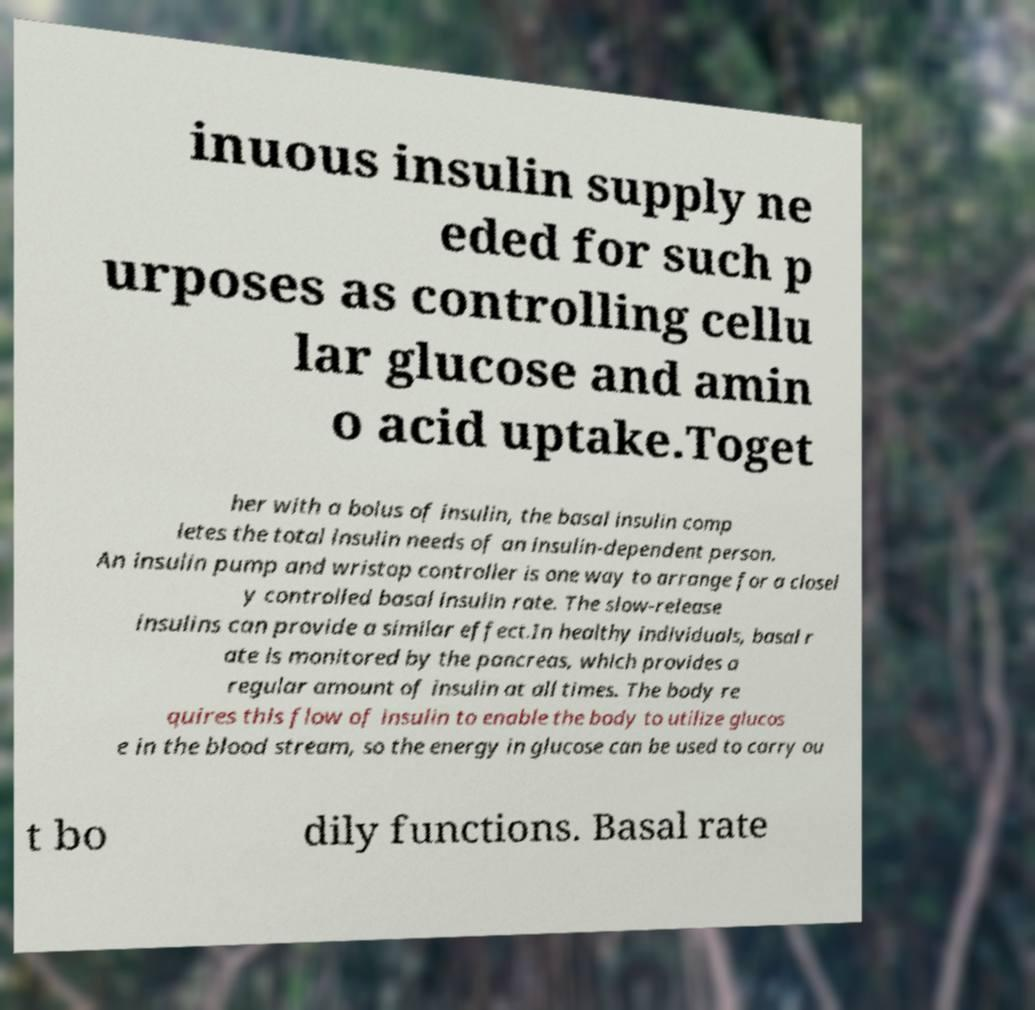Can you read and provide the text displayed in the image?This photo seems to have some interesting text. Can you extract and type it out for me? inuous insulin supply ne eded for such p urposes as controlling cellu lar glucose and amin o acid uptake.Toget her with a bolus of insulin, the basal insulin comp letes the total insulin needs of an insulin-dependent person. An insulin pump and wristop controller is one way to arrange for a closel y controlled basal insulin rate. The slow-release insulins can provide a similar effect.In healthy individuals, basal r ate is monitored by the pancreas, which provides a regular amount of insulin at all times. The body re quires this flow of insulin to enable the body to utilize glucos e in the blood stream, so the energy in glucose can be used to carry ou t bo dily functions. Basal rate 